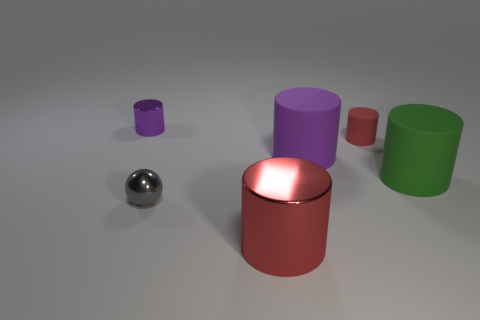Subtract all small red cylinders. How many cylinders are left? 4 Add 2 tiny spheres. How many objects exist? 8 Subtract 2 cylinders. How many cylinders are left? 3 Subtract all green cylinders. How many cylinders are left? 4 Subtract 0 purple balls. How many objects are left? 6 Subtract all spheres. How many objects are left? 5 Subtract all gray cylinders. Subtract all purple spheres. How many cylinders are left? 5 Subtract all brown balls. How many green cylinders are left? 1 Subtract all tiny cyan rubber cylinders. Subtract all cylinders. How many objects are left? 1 Add 3 tiny rubber objects. How many tiny rubber objects are left? 4 